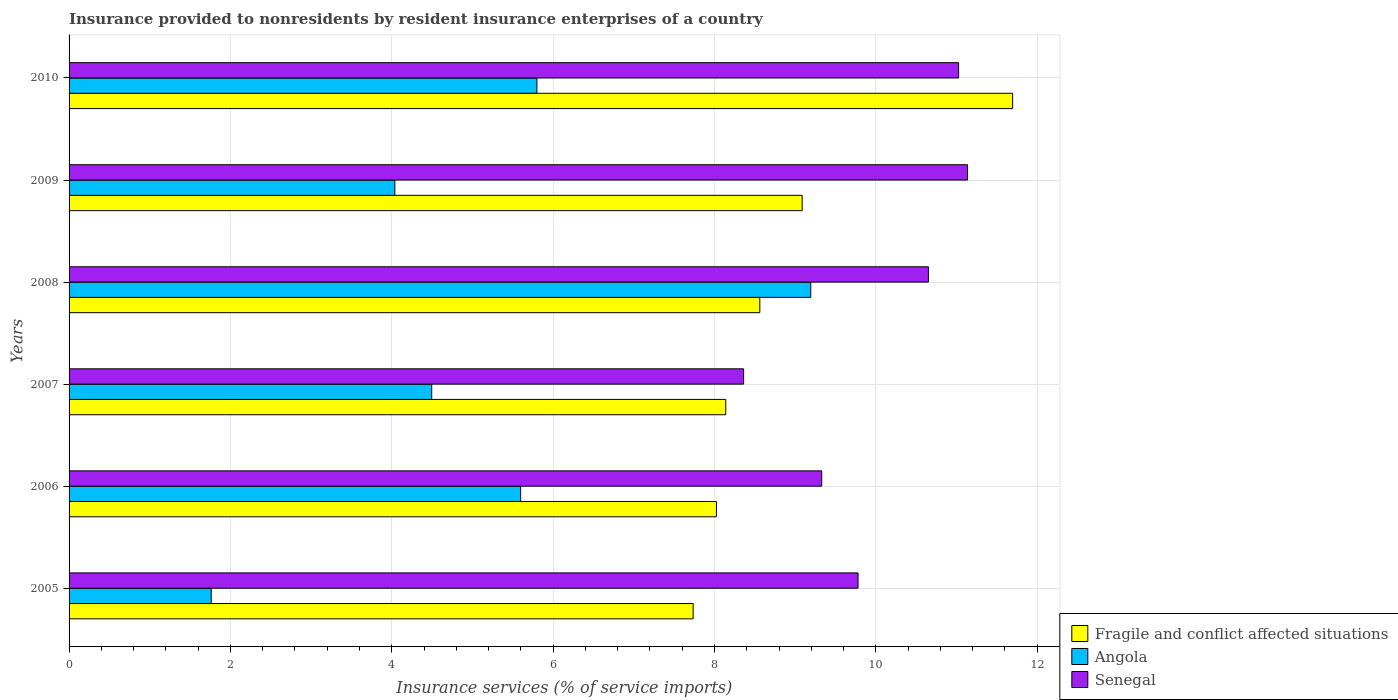How many different coloured bars are there?
Provide a succinct answer. 3. Are the number of bars per tick equal to the number of legend labels?
Your answer should be very brief. Yes. Are the number of bars on each tick of the Y-axis equal?
Give a very brief answer. Yes. How many bars are there on the 4th tick from the bottom?
Your response must be concise. 3. What is the label of the 4th group of bars from the top?
Your answer should be compact. 2007. What is the insurance provided to nonresidents in Fragile and conflict affected situations in 2007?
Your answer should be compact. 8.14. Across all years, what is the maximum insurance provided to nonresidents in Fragile and conflict affected situations?
Offer a terse response. 11.69. Across all years, what is the minimum insurance provided to nonresidents in Fragile and conflict affected situations?
Your answer should be compact. 7.73. In which year was the insurance provided to nonresidents in Fragile and conflict affected situations maximum?
Provide a succinct answer. 2010. In which year was the insurance provided to nonresidents in Angola minimum?
Provide a short and direct response. 2005. What is the total insurance provided to nonresidents in Senegal in the graph?
Offer a very short reply. 60.28. What is the difference between the insurance provided to nonresidents in Fragile and conflict affected situations in 2005 and that in 2010?
Your response must be concise. -3.96. What is the difference between the insurance provided to nonresidents in Senegal in 2005 and the insurance provided to nonresidents in Fragile and conflict affected situations in 2008?
Provide a succinct answer. 1.22. What is the average insurance provided to nonresidents in Senegal per year?
Your response must be concise. 10.05. In the year 2006, what is the difference between the insurance provided to nonresidents in Fragile and conflict affected situations and insurance provided to nonresidents in Senegal?
Provide a succinct answer. -1.3. What is the ratio of the insurance provided to nonresidents in Fragile and conflict affected situations in 2005 to that in 2007?
Provide a succinct answer. 0.95. Is the difference between the insurance provided to nonresidents in Fragile and conflict affected situations in 2006 and 2008 greater than the difference between the insurance provided to nonresidents in Senegal in 2006 and 2008?
Give a very brief answer. Yes. What is the difference between the highest and the second highest insurance provided to nonresidents in Senegal?
Provide a short and direct response. 0.11. What is the difference between the highest and the lowest insurance provided to nonresidents in Fragile and conflict affected situations?
Provide a succinct answer. 3.96. In how many years, is the insurance provided to nonresidents in Senegal greater than the average insurance provided to nonresidents in Senegal taken over all years?
Provide a succinct answer. 3. Is the sum of the insurance provided to nonresidents in Angola in 2008 and 2009 greater than the maximum insurance provided to nonresidents in Senegal across all years?
Ensure brevity in your answer.  Yes. What does the 2nd bar from the top in 2008 represents?
Provide a short and direct response. Angola. What does the 1st bar from the bottom in 2005 represents?
Your response must be concise. Fragile and conflict affected situations. Is it the case that in every year, the sum of the insurance provided to nonresidents in Angola and insurance provided to nonresidents in Senegal is greater than the insurance provided to nonresidents in Fragile and conflict affected situations?
Offer a very short reply. Yes. Are all the bars in the graph horizontal?
Ensure brevity in your answer.  Yes. How many years are there in the graph?
Give a very brief answer. 6. What is the difference between two consecutive major ticks on the X-axis?
Offer a very short reply. 2. Are the values on the major ticks of X-axis written in scientific E-notation?
Provide a short and direct response. No. Does the graph contain grids?
Ensure brevity in your answer.  Yes. Where does the legend appear in the graph?
Keep it short and to the point. Bottom right. How many legend labels are there?
Offer a very short reply. 3. How are the legend labels stacked?
Ensure brevity in your answer.  Vertical. What is the title of the graph?
Ensure brevity in your answer.  Insurance provided to nonresidents by resident insurance enterprises of a country. What is the label or title of the X-axis?
Offer a terse response. Insurance services (% of service imports). What is the label or title of the Y-axis?
Offer a terse response. Years. What is the Insurance services (% of service imports) in Fragile and conflict affected situations in 2005?
Offer a very short reply. 7.73. What is the Insurance services (% of service imports) of Angola in 2005?
Offer a terse response. 1.76. What is the Insurance services (% of service imports) of Senegal in 2005?
Offer a terse response. 9.78. What is the Insurance services (% of service imports) of Fragile and conflict affected situations in 2006?
Offer a terse response. 8.02. What is the Insurance services (% of service imports) in Angola in 2006?
Offer a terse response. 5.6. What is the Insurance services (% of service imports) of Senegal in 2006?
Provide a succinct answer. 9.33. What is the Insurance services (% of service imports) of Fragile and conflict affected situations in 2007?
Make the answer very short. 8.14. What is the Insurance services (% of service imports) in Angola in 2007?
Keep it short and to the point. 4.49. What is the Insurance services (% of service imports) in Senegal in 2007?
Offer a terse response. 8.36. What is the Insurance services (% of service imports) of Fragile and conflict affected situations in 2008?
Give a very brief answer. 8.56. What is the Insurance services (% of service imports) of Angola in 2008?
Your answer should be very brief. 9.19. What is the Insurance services (% of service imports) in Senegal in 2008?
Provide a short and direct response. 10.65. What is the Insurance services (% of service imports) of Fragile and conflict affected situations in 2009?
Give a very brief answer. 9.09. What is the Insurance services (% of service imports) of Angola in 2009?
Provide a succinct answer. 4.04. What is the Insurance services (% of service imports) of Senegal in 2009?
Your response must be concise. 11.13. What is the Insurance services (% of service imports) of Fragile and conflict affected situations in 2010?
Provide a short and direct response. 11.69. What is the Insurance services (% of service imports) of Angola in 2010?
Keep it short and to the point. 5.8. What is the Insurance services (% of service imports) of Senegal in 2010?
Ensure brevity in your answer.  11.03. Across all years, what is the maximum Insurance services (% of service imports) of Fragile and conflict affected situations?
Your answer should be compact. 11.69. Across all years, what is the maximum Insurance services (% of service imports) in Angola?
Your answer should be very brief. 9.19. Across all years, what is the maximum Insurance services (% of service imports) in Senegal?
Give a very brief answer. 11.13. Across all years, what is the minimum Insurance services (% of service imports) of Fragile and conflict affected situations?
Provide a short and direct response. 7.73. Across all years, what is the minimum Insurance services (% of service imports) in Angola?
Provide a short and direct response. 1.76. Across all years, what is the minimum Insurance services (% of service imports) in Senegal?
Your answer should be compact. 8.36. What is the total Insurance services (% of service imports) in Fragile and conflict affected situations in the graph?
Offer a very short reply. 53.24. What is the total Insurance services (% of service imports) in Angola in the graph?
Your response must be concise. 30.88. What is the total Insurance services (% of service imports) of Senegal in the graph?
Your answer should be compact. 60.28. What is the difference between the Insurance services (% of service imports) in Fragile and conflict affected situations in 2005 and that in 2006?
Give a very brief answer. -0.29. What is the difference between the Insurance services (% of service imports) of Angola in 2005 and that in 2006?
Ensure brevity in your answer.  -3.84. What is the difference between the Insurance services (% of service imports) in Senegal in 2005 and that in 2006?
Your response must be concise. 0.45. What is the difference between the Insurance services (% of service imports) in Fragile and conflict affected situations in 2005 and that in 2007?
Your response must be concise. -0.4. What is the difference between the Insurance services (% of service imports) in Angola in 2005 and that in 2007?
Offer a terse response. -2.73. What is the difference between the Insurance services (% of service imports) in Senegal in 2005 and that in 2007?
Make the answer very short. 1.42. What is the difference between the Insurance services (% of service imports) of Fragile and conflict affected situations in 2005 and that in 2008?
Offer a very short reply. -0.83. What is the difference between the Insurance services (% of service imports) of Angola in 2005 and that in 2008?
Provide a short and direct response. -7.43. What is the difference between the Insurance services (% of service imports) of Senegal in 2005 and that in 2008?
Make the answer very short. -0.87. What is the difference between the Insurance services (% of service imports) in Fragile and conflict affected situations in 2005 and that in 2009?
Offer a terse response. -1.35. What is the difference between the Insurance services (% of service imports) of Angola in 2005 and that in 2009?
Keep it short and to the point. -2.28. What is the difference between the Insurance services (% of service imports) in Senegal in 2005 and that in 2009?
Provide a succinct answer. -1.36. What is the difference between the Insurance services (% of service imports) of Fragile and conflict affected situations in 2005 and that in 2010?
Your response must be concise. -3.96. What is the difference between the Insurance services (% of service imports) in Angola in 2005 and that in 2010?
Offer a terse response. -4.04. What is the difference between the Insurance services (% of service imports) of Senegal in 2005 and that in 2010?
Your answer should be very brief. -1.25. What is the difference between the Insurance services (% of service imports) in Fragile and conflict affected situations in 2006 and that in 2007?
Keep it short and to the point. -0.12. What is the difference between the Insurance services (% of service imports) of Angola in 2006 and that in 2007?
Provide a succinct answer. 1.1. What is the difference between the Insurance services (% of service imports) of Senegal in 2006 and that in 2007?
Keep it short and to the point. 0.97. What is the difference between the Insurance services (% of service imports) of Fragile and conflict affected situations in 2006 and that in 2008?
Offer a terse response. -0.54. What is the difference between the Insurance services (% of service imports) in Angola in 2006 and that in 2008?
Give a very brief answer. -3.6. What is the difference between the Insurance services (% of service imports) of Senegal in 2006 and that in 2008?
Give a very brief answer. -1.32. What is the difference between the Insurance services (% of service imports) of Fragile and conflict affected situations in 2006 and that in 2009?
Offer a terse response. -1.06. What is the difference between the Insurance services (% of service imports) in Angola in 2006 and that in 2009?
Give a very brief answer. 1.56. What is the difference between the Insurance services (% of service imports) of Senegal in 2006 and that in 2009?
Provide a succinct answer. -1.81. What is the difference between the Insurance services (% of service imports) in Fragile and conflict affected situations in 2006 and that in 2010?
Your answer should be compact. -3.67. What is the difference between the Insurance services (% of service imports) in Angola in 2006 and that in 2010?
Ensure brevity in your answer.  -0.2. What is the difference between the Insurance services (% of service imports) of Senegal in 2006 and that in 2010?
Provide a succinct answer. -1.7. What is the difference between the Insurance services (% of service imports) of Fragile and conflict affected situations in 2007 and that in 2008?
Offer a very short reply. -0.42. What is the difference between the Insurance services (% of service imports) in Angola in 2007 and that in 2008?
Give a very brief answer. -4.7. What is the difference between the Insurance services (% of service imports) of Senegal in 2007 and that in 2008?
Provide a short and direct response. -2.29. What is the difference between the Insurance services (% of service imports) in Fragile and conflict affected situations in 2007 and that in 2009?
Your answer should be very brief. -0.95. What is the difference between the Insurance services (% of service imports) in Angola in 2007 and that in 2009?
Give a very brief answer. 0.46. What is the difference between the Insurance services (% of service imports) of Senegal in 2007 and that in 2009?
Provide a short and direct response. -2.77. What is the difference between the Insurance services (% of service imports) in Fragile and conflict affected situations in 2007 and that in 2010?
Your answer should be compact. -3.56. What is the difference between the Insurance services (% of service imports) of Angola in 2007 and that in 2010?
Your answer should be very brief. -1.3. What is the difference between the Insurance services (% of service imports) of Senegal in 2007 and that in 2010?
Make the answer very short. -2.67. What is the difference between the Insurance services (% of service imports) in Fragile and conflict affected situations in 2008 and that in 2009?
Make the answer very short. -0.53. What is the difference between the Insurance services (% of service imports) of Angola in 2008 and that in 2009?
Give a very brief answer. 5.15. What is the difference between the Insurance services (% of service imports) in Senegal in 2008 and that in 2009?
Your answer should be compact. -0.48. What is the difference between the Insurance services (% of service imports) in Fragile and conflict affected situations in 2008 and that in 2010?
Keep it short and to the point. -3.13. What is the difference between the Insurance services (% of service imports) of Angola in 2008 and that in 2010?
Keep it short and to the point. 3.39. What is the difference between the Insurance services (% of service imports) in Senegal in 2008 and that in 2010?
Your answer should be compact. -0.37. What is the difference between the Insurance services (% of service imports) in Fragile and conflict affected situations in 2009 and that in 2010?
Provide a succinct answer. -2.61. What is the difference between the Insurance services (% of service imports) in Angola in 2009 and that in 2010?
Keep it short and to the point. -1.76. What is the difference between the Insurance services (% of service imports) in Senegal in 2009 and that in 2010?
Your response must be concise. 0.11. What is the difference between the Insurance services (% of service imports) in Fragile and conflict affected situations in 2005 and the Insurance services (% of service imports) in Angola in 2006?
Keep it short and to the point. 2.14. What is the difference between the Insurance services (% of service imports) in Fragile and conflict affected situations in 2005 and the Insurance services (% of service imports) in Senegal in 2006?
Give a very brief answer. -1.59. What is the difference between the Insurance services (% of service imports) in Angola in 2005 and the Insurance services (% of service imports) in Senegal in 2006?
Make the answer very short. -7.57. What is the difference between the Insurance services (% of service imports) of Fragile and conflict affected situations in 2005 and the Insurance services (% of service imports) of Angola in 2007?
Make the answer very short. 3.24. What is the difference between the Insurance services (% of service imports) of Fragile and conflict affected situations in 2005 and the Insurance services (% of service imports) of Senegal in 2007?
Your answer should be very brief. -0.63. What is the difference between the Insurance services (% of service imports) of Angola in 2005 and the Insurance services (% of service imports) of Senegal in 2007?
Provide a succinct answer. -6.6. What is the difference between the Insurance services (% of service imports) of Fragile and conflict affected situations in 2005 and the Insurance services (% of service imports) of Angola in 2008?
Provide a succinct answer. -1.46. What is the difference between the Insurance services (% of service imports) in Fragile and conflict affected situations in 2005 and the Insurance services (% of service imports) in Senegal in 2008?
Give a very brief answer. -2.92. What is the difference between the Insurance services (% of service imports) in Angola in 2005 and the Insurance services (% of service imports) in Senegal in 2008?
Your answer should be very brief. -8.89. What is the difference between the Insurance services (% of service imports) in Fragile and conflict affected situations in 2005 and the Insurance services (% of service imports) in Angola in 2009?
Your answer should be very brief. 3.7. What is the difference between the Insurance services (% of service imports) in Fragile and conflict affected situations in 2005 and the Insurance services (% of service imports) in Senegal in 2009?
Your response must be concise. -3.4. What is the difference between the Insurance services (% of service imports) of Angola in 2005 and the Insurance services (% of service imports) of Senegal in 2009?
Provide a succinct answer. -9.37. What is the difference between the Insurance services (% of service imports) of Fragile and conflict affected situations in 2005 and the Insurance services (% of service imports) of Angola in 2010?
Ensure brevity in your answer.  1.94. What is the difference between the Insurance services (% of service imports) in Fragile and conflict affected situations in 2005 and the Insurance services (% of service imports) in Senegal in 2010?
Your response must be concise. -3.29. What is the difference between the Insurance services (% of service imports) of Angola in 2005 and the Insurance services (% of service imports) of Senegal in 2010?
Provide a short and direct response. -9.26. What is the difference between the Insurance services (% of service imports) in Fragile and conflict affected situations in 2006 and the Insurance services (% of service imports) in Angola in 2007?
Your answer should be compact. 3.53. What is the difference between the Insurance services (% of service imports) of Fragile and conflict affected situations in 2006 and the Insurance services (% of service imports) of Senegal in 2007?
Keep it short and to the point. -0.34. What is the difference between the Insurance services (% of service imports) in Angola in 2006 and the Insurance services (% of service imports) in Senegal in 2007?
Keep it short and to the point. -2.76. What is the difference between the Insurance services (% of service imports) of Fragile and conflict affected situations in 2006 and the Insurance services (% of service imports) of Angola in 2008?
Provide a succinct answer. -1.17. What is the difference between the Insurance services (% of service imports) of Fragile and conflict affected situations in 2006 and the Insurance services (% of service imports) of Senegal in 2008?
Your answer should be compact. -2.63. What is the difference between the Insurance services (% of service imports) of Angola in 2006 and the Insurance services (% of service imports) of Senegal in 2008?
Provide a short and direct response. -5.05. What is the difference between the Insurance services (% of service imports) of Fragile and conflict affected situations in 2006 and the Insurance services (% of service imports) of Angola in 2009?
Provide a short and direct response. 3.99. What is the difference between the Insurance services (% of service imports) in Fragile and conflict affected situations in 2006 and the Insurance services (% of service imports) in Senegal in 2009?
Your answer should be compact. -3.11. What is the difference between the Insurance services (% of service imports) of Angola in 2006 and the Insurance services (% of service imports) of Senegal in 2009?
Offer a terse response. -5.54. What is the difference between the Insurance services (% of service imports) of Fragile and conflict affected situations in 2006 and the Insurance services (% of service imports) of Angola in 2010?
Your answer should be compact. 2.23. What is the difference between the Insurance services (% of service imports) in Fragile and conflict affected situations in 2006 and the Insurance services (% of service imports) in Senegal in 2010?
Offer a terse response. -3. What is the difference between the Insurance services (% of service imports) of Angola in 2006 and the Insurance services (% of service imports) of Senegal in 2010?
Provide a succinct answer. -5.43. What is the difference between the Insurance services (% of service imports) in Fragile and conflict affected situations in 2007 and the Insurance services (% of service imports) in Angola in 2008?
Provide a short and direct response. -1.05. What is the difference between the Insurance services (% of service imports) of Fragile and conflict affected situations in 2007 and the Insurance services (% of service imports) of Senegal in 2008?
Provide a short and direct response. -2.51. What is the difference between the Insurance services (% of service imports) in Angola in 2007 and the Insurance services (% of service imports) in Senegal in 2008?
Ensure brevity in your answer.  -6.16. What is the difference between the Insurance services (% of service imports) in Fragile and conflict affected situations in 2007 and the Insurance services (% of service imports) in Angola in 2009?
Offer a terse response. 4.1. What is the difference between the Insurance services (% of service imports) in Fragile and conflict affected situations in 2007 and the Insurance services (% of service imports) in Senegal in 2009?
Your response must be concise. -3. What is the difference between the Insurance services (% of service imports) in Angola in 2007 and the Insurance services (% of service imports) in Senegal in 2009?
Your answer should be very brief. -6.64. What is the difference between the Insurance services (% of service imports) in Fragile and conflict affected situations in 2007 and the Insurance services (% of service imports) in Angola in 2010?
Offer a very short reply. 2.34. What is the difference between the Insurance services (% of service imports) of Fragile and conflict affected situations in 2007 and the Insurance services (% of service imports) of Senegal in 2010?
Give a very brief answer. -2.89. What is the difference between the Insurance services (% of service imports) of Angola in 2007 and the Insurance services (% of service imports) of Senegal in 2010?
Ensure brevity in your answer.  -6.53. What is the difference between the Insurance services (% of service imports) in Fragile and conflict affected situations in 2008 and the Insurance services (% of service imports) in Angola in 2009?
Give a very brief answer. 4.52. What is the difference between the Insurance services (% of service imports) in Fragile and conflict affected situations in 2008 and the Insurance services (% of service imports) in Senegal in 2009?
Make the answer very short. -2.57. What is the difference between the Insurance services (% of service imports) of Angola in 2008 and the Insurance services (% of service imports) of Senegal in 2009?
Offer a terse response. -1.94. What is the difference between the Insurance services (% of service imports) of Fragile and conflict affected situations in 2008 and the Insurance services (% of service imports) of Angola in 2010?
Give a very brief answer. 2.76. What is the difference between the Insurance services (% of service imports) in Fragile and conflict affected situations in 2008 and the Insurance services (% of service imports) in Senegal in 2010?
Provide a succinct answer. -2.46. What is the difference between the Insurance services (% of service imports) in Angola in 2008 and the Insurance services (% of service imports) in Senegal in 2010?
Provide a short and direct response. -1.83. What is the difference between the Insurance services (% of service imports) of Fragile and conflict affected situations in 2009 and the Insurance services (% of service imports) of Angola in 2010?
Your response must be concise. 3.29. What is the difference between the Insurance services (% of service imports) in Fragile and conflict affected situations in 2009 and the Insurance services (% of service imports) in Senegal in 2010?
Ensure brevity in your answer.  -1.94. What is the difference between the Insurance services (% of service imports) of Angola in 2009 and the Insurance services (% of service imports) of Senegal in 2010?
Provide a succinct answer. -6.99. What is the average Insurance services (% of service imports) in Fragile and conflict affected situations per year?
Provide a short and direct response. 8.87. What is the average Insurance services (% of service imports) in Angola per year?
Keep it short and to the point. 5.15. What is the average Insurance services (% of service imports) of Senegal per year?
Keep it short and to the point. 10.05. In the year 2005, what is the difference between the Insurance services (% of service imports) in Fragile and conflict affected situations and Insurance services (% of service imports) in Angola?
Give a very brief answer. 5.97. In the year 2005, what is the difference between the Insurance services (% of service imports) in Fragile and conflict affected situations and Insurance services (% of service imports) in Senegal?
Offer a terse response. -2.04. In the year 2005, what is the difference between the Insurance services (% of service imports) of Angola and Insurance services (% of service imports) of Senegal?
Provide a succinct answer. -8.02. In the year 2006, what is the difference between the Insurance services (% of service imports) in Fragile and conflict affected situations and Insurance services (% of service imports) in Angola?
Keep it short and to the point. 2.43. In the year 2006, what is the difference between the Insurance services (% of service imports) in Fragile and conflict affected situations and Insurance services (% of service imports) in Senegal?
Your response must be concise. -1.3. In the year 2006, what is the difference between the Insurance services (% of service imports) in Angola and Insurance services (% of service imports) in Senegal?
Your response must be concise. -3.73. In the year 2007, what is the difference between the Insurance services (% of service imports) of Fragile and conflict affected situations and Insurance services (% of service imports) of Angola?
Ensure brevity in your answer.  3.64. In the year 2007, what is the difference between the Insurance services (% of service imports) in Fragile and conflict affected situations and Insurance services (% of service imports) in Senegal?
Give a very brief answer. -0.22. In the year 2007, what is the difference between the Insurance services (% of service imports) of Angola and Insurance services (% of service imports) of Senegal?
Give a very brief answer. -3.87. In the year 2008, what is the difference between the Insurance services (% of service imports) of Fragile and conflict affected situations and Insurance services (% of service imports) of Angola?
Offer a terse response. -0.63. In the year 2008, what is the difference between the Insurance services (% of service imports) of Fragile and conflict affected situations and Insurance services (% of service imports) of Senegal?
Provide a succinct answer. -2.09. In the year 2008, what is the difference between the Insurance services (% of service imports) in Angola and Insurance services (% of service imports) in Senegal?
Offer a very short reply. -1.46. In the year 2009, what is the difference between the Insurance services (% of service imports) in Fragile and conflict affected situations and Insurance services (% of service imports) in Angola?
Make the answer very short. 5.05. In the year 2009, what is the difference between the Insurance services (% of service imports) of Fragile and conflict affected situations and Insurance services (% of service imports) of Senegal?
Offer a terse response. -2.05. In the year 2009, what is the difference between the Insurance services (% of service imports) of Angola and Insurance services (% of service imports) of Senegal?
Make the answer very short. -7.1. In the year 2010, what is the difference between the Insurance services (% of service imports) in Fragile and conflict affected situations and Insurance services (% of service imports) in Angola?
Make the answer very short. 5.9. In the year 2010, what is the difference between the Insurance services (% of service imports) in Fragile and conflict affected situations and Insurance services (% of service imports) in Senegal?
Provide a succinct answer. 0.67. In the year 2010, what is the difference between the Insurance services (% of service imports) of Angola and Insurance services (% of service imports) of Senegal?
Your response must be concise. -5.23. What is the ratio of the Insurance services (% of service imports) of Angola in 2005 to that in 2006?
Give a very brief answer. 0.31. What is the ratio of the Insurance services (% of service imports) in Senegal in 2005 to that in 2006?
Make the answer very short. 1.05. What is the ratio of the Insurance services (% of service imports) of Fragile and conflict affected situations in 2005 to that in 2007?
Your answer should be compact. 0.95. What is the ratio of the Insurance services (% of service imports) in Angola in 2005 to that in 2007?
Offer a very short reply. 0.39. What is the ratio of the Insurance services (% of service imports) in Senegal in 2005 to that in 2007?
Ensure brevity in your answer.  1.17. What is the ratio of the Insurance services (% of service imports) in Fragile and conflict affected situations in 2005 to that in 2008?
Keep it short and to the point. 0.9. What is the ratio of the Insurance services (% of service imports) of Angola in 2005 to that in 2008?
Offer a very short reply. 0.19. What is the ratio of the Insurance services (% of service imports) of Senegal in 2005 to that in 2008?
Your answer should be compact. 0.92. What is the ratio of the Insurance services (% of service imports) in Fragile and conflict affected situations in 2005 to that in 2009?
Provide a short and direct response. 0.85. What is the ratio of the Insurance services (% of service imports) of Angola in 2005 to that in 2009?
Offer a terse response. 0.44. What is the ratio of the Insurance services (% of service imports) of Senegal in 2005 to that in 2009?
Your response must be concise. 0.88. What is the ratio of the Insurance services (% of service imports) in Fragile and conflict affected situations in 2005 to that in 2010?
Offer a terse response. 0.66. What is the ratio of the Insurance services (% of service imports) of Angola in 2005 to that in 2010?
Make the answer very short. 0.3. What is the ratio of the Insurance services (% of service imports) of Senegal in 2005 to that in 2010?
Provide a short and direct response. 0.89. What is the ratio of the Insurance services (% of service imports) of Fragile and conflict affected situations in 2006 to that in 2007?
Your answer should be compact. 0.99. What is the ratio of the Insurance services (% of service imports) in Angola in 2006 to that in 2007?
Your response must be concise. 1.25. What is the ratio of the Insurance services (% of service imports) in Senegal in 2006 to that in 2007?
Ensure brevity in your answer.  1.12. What is the ratio of the Insurance services (% of service imports) of Fragile and conflict affected situations in 2006 to that in 2008?
Your answer should be very brief. 0.94. What is the ratio of the Insurance services (% of service imports) of Angola in 2006 to that in 2008?
Your answer should be compact. 0.61. What is the ratio of the Insurance services (% of service imports) of Senegal in 2006 to that in 2008?
Keep it short and to the point. 0.88. What is the ratio of the Insurance services (% of service imports) of Fragile and conflict affected situations in 2006 to that in 2009?
Keep it short and to the point. 0.88. What is the ratio of the Insurance services (% of service imports) in Angola in 2006 to that in 2009?
Offer a terse response. 1.39. What is the ratio of the Insurance services (% of service imports) of Senegal in 2006 to that in 2009?
Your response must be concise. 0.84. What is the ratio of the Insurance services (% of service imports) of Fragile and conflict affected situations in 2006 to that in 2010?
Give a very brief answer. 0.69. What is the ratio of the Insurance services (% of service imports) of Angola in 2006 to that in 2010?
Your answer should be very brief. 0.97. What is the ratio of the Insurance services (% of service imports) in Senegal in 2006 to that in 2010?
Your response must be concise. 0.85. What is the ratio of the Insurance services (% of service imports) of Fragile and conflict affected situations in 2007 to that in 2008?
Give a very brief answer. 0.95. What is the ratio of the Insurance services (% of service imports) of Angola in 2007 to that in 2008?
Offer a very short reply. 0.49. What is the ratio of the Insurance services (% of service imports) in Senegal in 2007 to that in 2008?
Keep it short and to the point. 0.78. What is the ratio of the Insurance services (% of service imports) in Fragile and conflict affected situations in 2007 to that in 2009?
Provide a succinct answer. 0.9. What is the ratio of the Insurance services (% of service imports) of Angola in 2007 to that in 2009?
Keep it short and to the point. 1.11. What is the ratio of the Insurance services (% of service imports) in Senegal in 2007 to that in 2009?
Your answer should be compact. 0.75. What is the ratio of the Insurance services (% of service imports) in Fragile and conflict affected situations in 2007 to that in 2010?
Your response must be concise. 0.7. What is the ratio of the Insurance services (% of service imports) of Angola in 2007 to that in 2010?
Make the answer very short. 0.78. What is the ratio of the Insurance services (% of service imports) of Senegal in 2007 to that in 2010?
Provide a short and direct response. 0.76. What is the ratio of the Insurance services (% of service imports) of Fragile and conflict affected situations in 2008 to that in 2009?
Your answer should be very brief. 0.94. What is the ratio of the Insurance services (% of service imports) in Angola in 2008 to that in 2009?
Offer a very short reply. 2.28. What is the ratio of the Insurance services (% of service imports) of Senegal in 2008 to that in 2009?
Your answer should be compact. 0.96. What is the ratio of the Insurance services (% of service imports) in Fragile and conflict affected situations in 2008 to that in 2010?
Your response must be concise. 0.73. What is the ratio of the Insurance services (% of service imports) in Angola in 2008 to that in 2010?
Ensure brevity in your answer.  1.59. What is the ratio of the Insurance services (% of service imports) in Fragile and conflict affected situations in 2009 to that in 2010?
Your answer should be compact. 0.78. What is the ratio of the Insurance services (% of service imports) in Angola in 2009 to that in 2010?
Your answer should be compact. 0.7. What is the ratio of the Insurance services (% of service imports) in Senegal in 2009 to that in 2010?
Provide a succinct answer. 1.01. What is the difference between the highest and the second highest Insurance services (% of service imports) of Fragile and conflict affected situations?
Your response must be concise. 2.61. What is the difference between the highest and the second highest Insurance services (% of service imports) of Angola?
Your answer should be compact. 3.39. What is the difference between the highest and the second highest Insurance services (% of service imports) of Senegal?
Your answer should be very brief. 0.11. What is the difference between the highest and the lowest Insurance services (% of service imports) of Fragile and conflict affected situations?
Offer a very short reply. 3.96. What is the difference between the highest and the lowest Insurance services (% of service imports) in Angola?
Offer a very short reply. 7.43. What is the difference between the highest and the lowest Insurance services (% of service imports) in Senegal?
Your answer should be very brief. 2.77. 